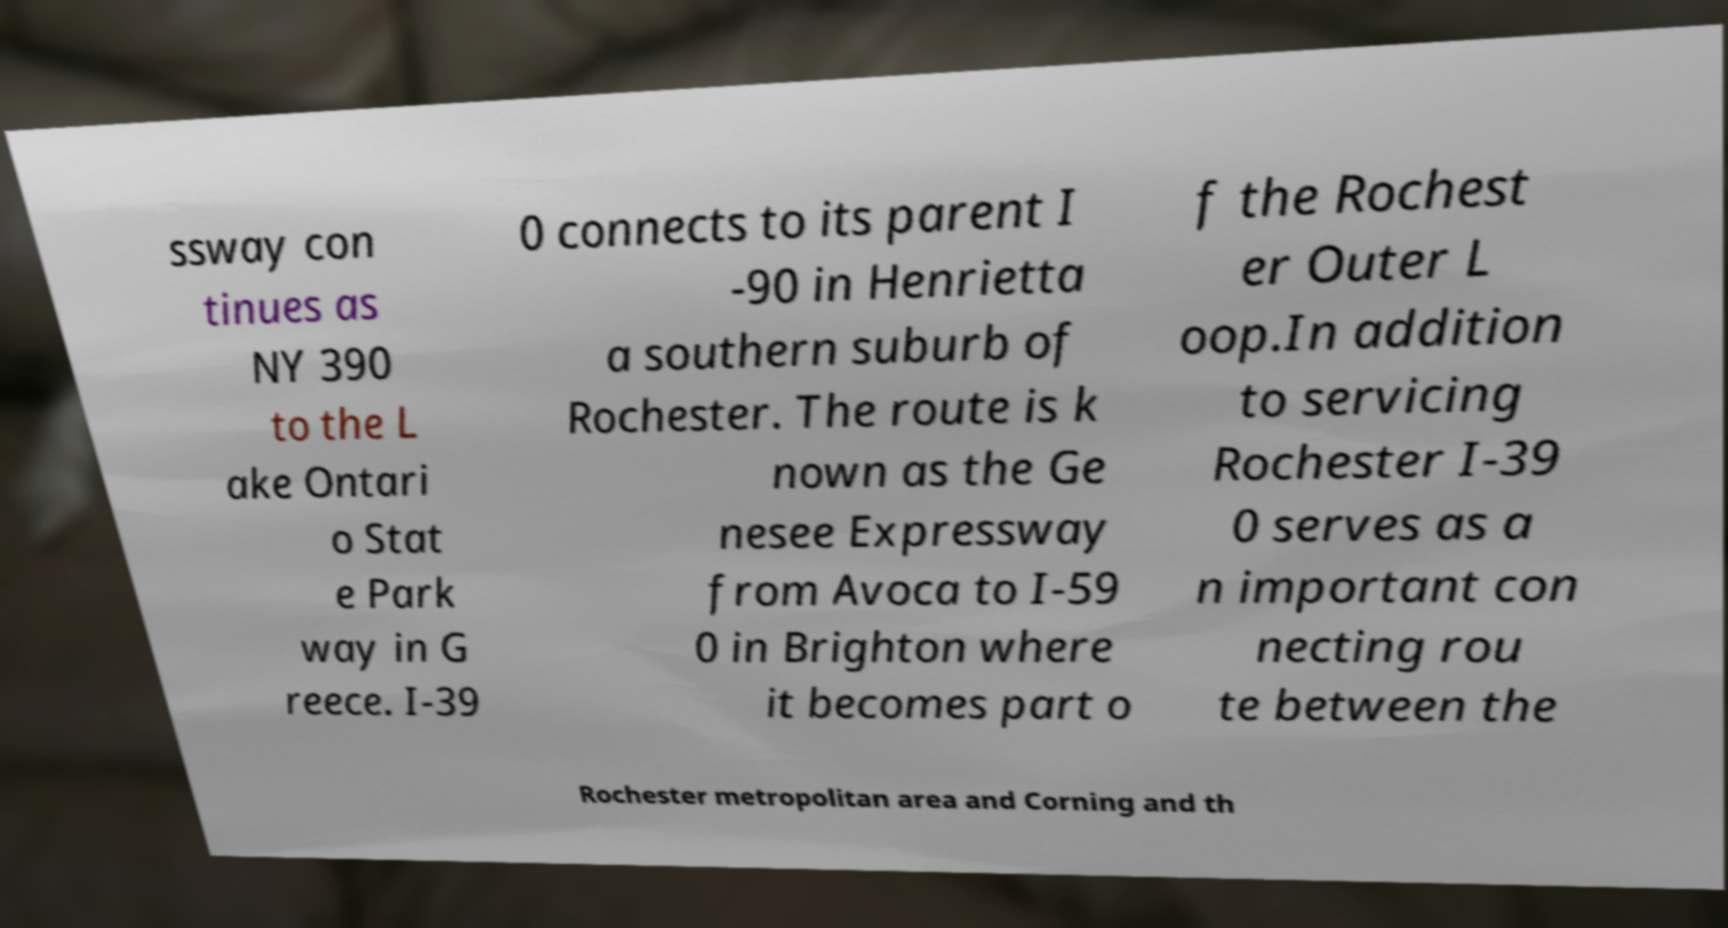Could you assist in decoding the text presented in this image and type it out clearly? ssway con tinues as NY 390 to the L ake Ontari o Stat e Park way in G reece. I-39 0 connects to its parent I -90 in Henrietta a southern suburb of Rochester. The route is k nown as the Ge nesee Expressway from Avoca to I-59 0 in Brighton where it becomes part o f the Rochest er Outer L oop.In addition to servicing Rochester I-39 0 serves as a n important con necting rou te between the Rochester metropolitan area and Corning and th 